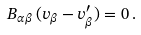Convert formula to latex. <formula><loc_0><loc_0><loc_500><loc_500>B _ { \alpha \beta } \, ( v _ { \beta } - v _ { \beta } ^ { \prime } ) = 0 \, .</formula> 